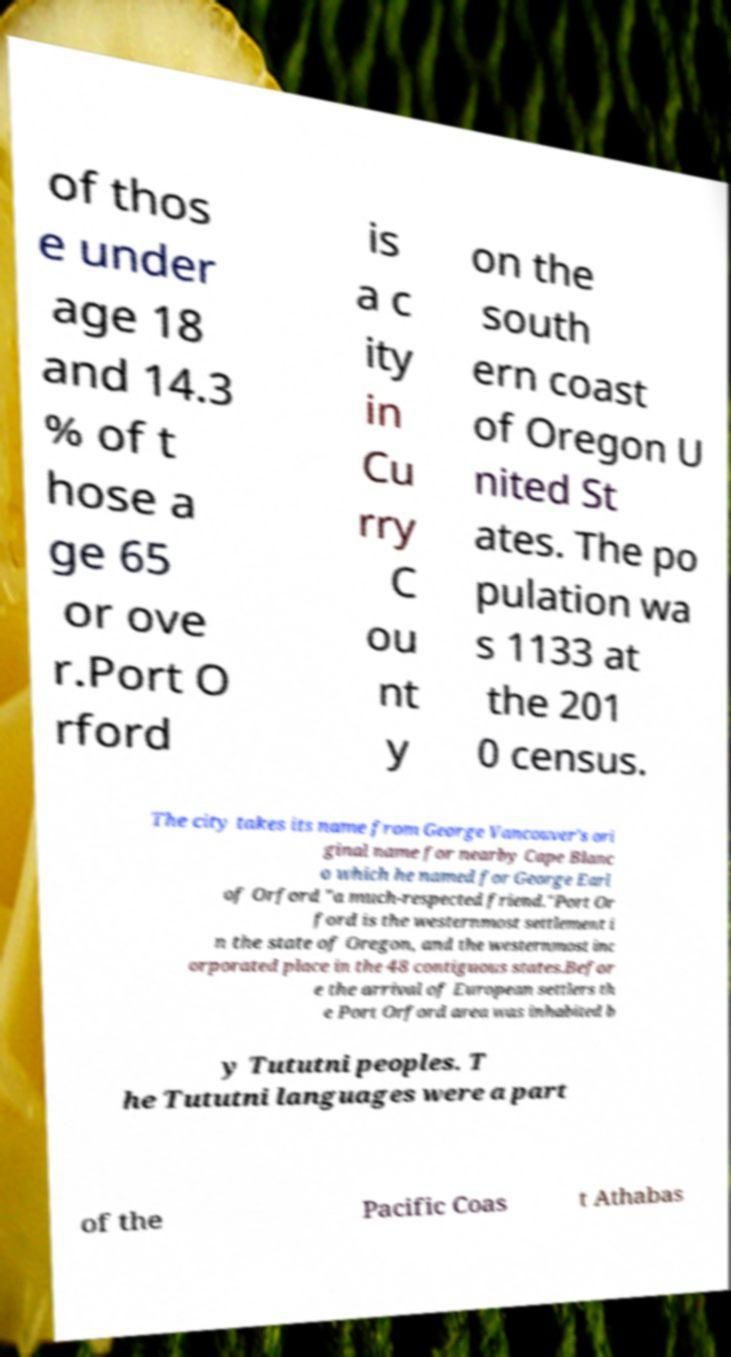Can you accurately transcribe the text from the provided image for me? of thos e under age 18 and 14.3 % of t hose a ge 65 or ove r.Port O rford is a c ity in Cu rry C ou nt y on the south ern coast of Oregon U nited St ates. The po pulation wa s 1133 at the 201 0 census. The city takes its name from George Vancouver's ori ginal name for nearby Cape Blanc o which he named for George Earl of Orford "a much-respected friend."Port Or ford is the westernmost settlement i n the state of Oregon, and the westernmost inc orporated place in the 48 contiguous states.Befor e the arrival of European settlers th e Port Orford area was inhabited b y Tututni peoples. T he Tututni languages were a part of the Pacific Coas t Athabas 